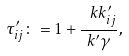<formula> <loc_0><loc_0><loc_500><loc_500>\tau ^ { \prime } _ { i j } \colon = 1 + \frac { \ k k ^ { \prime } _ { i j } } { k ^ { \prime } \gamma } ,</formula> 